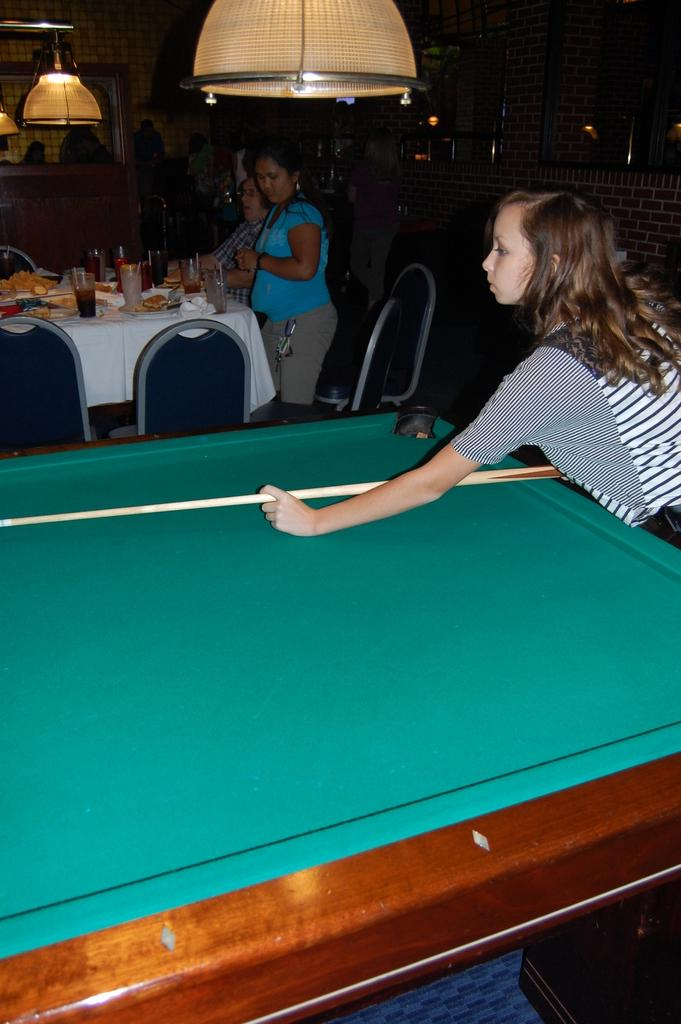What is the girl in the image doing? The girl is playing soccer in the image. What can be seen in the background of the image? There are people, chairs, glasses, food items on a table, and a light hanging from the roof top in the background of the image. Can you see any cakes on the mountain in the image? There is no mountain or cakes present in the image. How does the girl blow the soccer ball in the image? The girl is not blowing the soccer ball in the image; she is playing soccer by kicking the ball. 